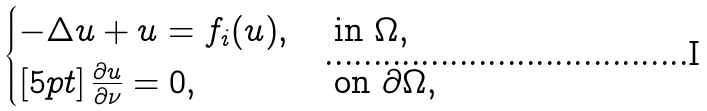<formula> <loc_0><loc_0><loc_500><loc_500>\begin{cases} - \Delta u + u = f _ { i } ( u ) , & \text { in } \Omega , \\ [ 5 p t ] \, \frac { \partial u } { \partial \nu } = 0 , & \text { on } \partial \Omega , \end{cases}</formula> 